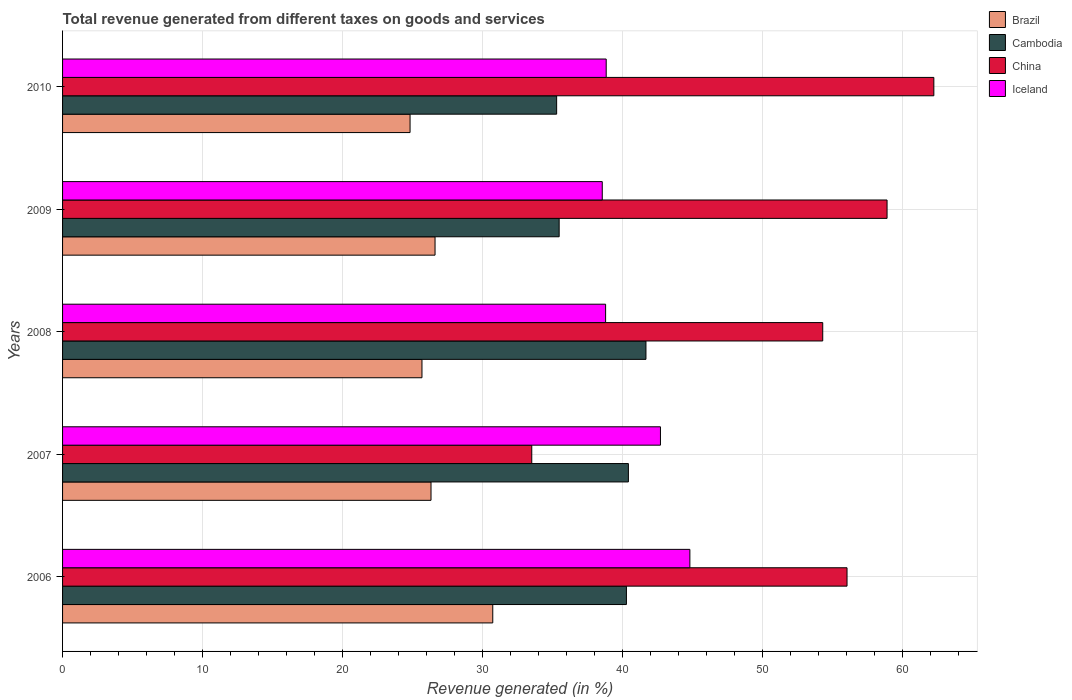Are the number of bars per tick equal to the number of legend labels?
Provide a short and direct response. Yes. Are the number of bars on each tick of the Y-axis equal?
Give a very brief answer. Yes. How many bars are there on the 1st tick from the top?
Your response must be concise. 4. What is the total revenue generated in Cambodia in 2008?
Your response must be concise. 41.67. Across all years, what is the maximum total revenue generated in China?
Your response must be concise. 62.23. Across all years, what is the minimum total revenue generated in Brazil?
Offer a terse response. 24.82. In which year was the total revenue generated in Cambodia maximum?
Keep it short and to the point. 2008. In which year was the total revenue generated in Brazil minimum?
Offer a very short reply. 2010. What is the total total revenue generated in Cambodia in the graph?
Keep it short and to the point. 193.12. What is the difference between the total revenue generated in Iceland in 2007 and that in 2008?
Your response must be concise. 3.92. What is the difference between the total revenue generated in Brazil in 2006 and the total revenue generated in Cambodia in 2009?
Your answer should be very brief. -4.74. What is the average total revenue generated in Iceland per year?
Offer a very short reply. 40.74. In the year 2008, what is the difference between the total revenue generated in Cambodia and total revenue generated in Brazil?
Offer a terse response. 16. What is the ratio of the total revenue generated in China in 2007 to that in 2010?
Your response must be concise. 0.54. Is the difference between the total revenue generated in Cambodia in 2006 and 2008 greater than the difference between the total revenue generated in Brazil in 2006 and 2008?
Offer a very short reply. No. What is the difference between the highest and the second highest total revenue generated in Cambodia?
Give a very brief answer. 1.25. What is the difference between the highest and the lowest total revenue generated in China?
Keep it short and to the point. 28.72. In how many years, is the total revenue generated in Brazil greater than the average total revenue generated in Brazil taken over all years?
Ensure brevity in your answer.  1. Is it the case that in every year, the sum of the total revenue generated in Cambodia and total revenue generated in China is greater than the sum of total revenue generated in Brazil and total revenue generated in Iceland?
Offer a terse response. Yes. What does the 3rd bar from the top in 2010 represents?
Make the answer very short. Cambodia. What does the 2nd bar from the bottom in 2009 represents?
Provide a short and direct response. Cambodia. Is it the case that in every year, the sum of the total revenue generated in China and total revenue generated in Brazil is greater than the total revenue generated in Iceland?
Provide a short and direct response. Yes. How many bars are there?
Your answer should be compact. 20. Are all the bars in the graph horizontal?
Provide a short and direct response. Yes. What is the difference between two consecutive major ticks on the X-axis?
Keep it short and to the point. 10. Are the values on the major ticks of X-axis written in scientific E-notation?
Your response must be concise. No. Does the graph contain grids?
Offer a very short reply. Yes. How are the legend labels stacked?
Offer a terse response. Vertical. What is the title of the graph?
Provide a short and direct response. Total revenue generated from different taxes on goods and services. What is the label or title of the X-axis?
Offer a very short reply. Revenue generated (in %). What is the Revenue generated (in %) of Brazil in 2006?
Ensure brevity in your answer.  30.73. What is the Revenue generated (in %) of Cambodia in 2006?
Your answer should be very brief. 40.28. What is the Revenue generated (in %) of China in 2006?
Give a very brief answer. 56.03. What is the Revenue generated (in %) in Iceland in 2006?
Provide a succinct answer. 44.81. What is the Revenue generated (in %) in Brazil in 2007?
Provide a succinct answer. 26.32. What is the Revenue generated (in %) in Cambodia in 2007?
Provide a short and direct response. 40.42. What is the Revenue generated (in %) of China in 2007?
Offer a very short reply. 33.51. What is the Revenue generated (in %) in Iceland in 2007?
Keep it short and to the point. 42.71. What is the Revenue generated (in %) in Brazil in 2008?
Provide a succinct answer. 25.67. What is the Revenue generated (in %) of Cambodia in 2008?
Make the answer very short. 41.67. What is the Revenue generated (in %) of China in 2008?
Ensure brevity in your answer.  54.3. What is the Revenue generated (in %) of Iceland in 2008?
Offer a terse response. 38.79. What is the Revenue generated (in %) in Brazil in 2009?
Your response must be concise. 26.61. What is the Revenue generated (in %) of Cambodia in 2009?
Give a very brief answer. 35.47. What is the Revenue generated (in %) in China in 2009?
Offer a terse response. 58.89. What is the Revenue generated (in %) in Iceland in 2009?
Your answer should be very brief. 38.55. What is the Revenue generated (in %) in Brazil in 2010?
Offer a very short reply. 24.82. What is the Revenue generated (in %) in Cambodia in 2010?
Offer a terse response. 35.29. What is the Revenue generated (in %) of China in 2010?
Your answer should be compact. 62.23. What is the Revenue generated (in %) of Iceland in 2010?
Give a very brief answer. 38.83. Across all years, what is the maximum Revenue generated (in %) of Brazil?
Provide a short and direct response. 30.73. Across all years, what is the maximum Revenue generated (in %) in Cambodia?
Offer a very short reply. 41.67. Across all years, what is the maximum Revenue generated (in %) of China?
Keep it short and to the point. 62.23. Across all years, what is the maximum Revenue generated (in %) of Iceland?
Your response must be concise. 44.81. Across all years, what is the minimum Revenue generated (in %) of Brazil?
Your answer should be very brief. 24.82. Across all years, what is the minimum Revenue generated (in %) of Cambodia?
Your response must be concise. 35.29. Across all years, what is the minimum Revenue generated (in %) of China?
Ensure brevity in your answer.  33.51. Across all years, what is the minimum Revenue generated (in %) of Iceland?
Keep it short and to the point. 38.55. What is the total Revenue generated (in %) of Brazil in the graph?
Provide a short and direct response. 134.14. What is the total Revenue generated (in %) in Cambodia in the graph?
Your answer should be compact. 193.12. What is the total Revenue generated (in %) in China in the graph?
Keep it short and to the point. 264.97. What is the total Revenue generated (in %) in Iceland in the graph?
Keep it short and to the point. 203.68. What is the difference between the Revenue generated (in %) of Brazil in 2006 and that in 2007?
Offer a very short reply. 4.41. What is the difference between the Revenue generated (in %) in Cambodia in 2006 and that in 2007?
Ensure brevity in your answer.  -0.14. What is the difference between the Revenue generated (in %) in China in 2006 and that in 2007?
Keep it short and to the point. 22.52. What is the difference between the Revenue generated (in %) of Iceland in 2006 and that in 2007?
Your response must be concise. 2.1. What is the difference between the Revenue generated (in %) in Brazil in 2006 and that in 2008?
Offer a very short reply. 5.06. What is the difference between the Revenue generated (in %) of Cambodia in 2006 and that in 2008?
Your answer should be very brief. -1.39. What is the difference between the Revenue generated (in %) in China in 2006 and that in 2008?
Keep it short and to the point. 1.73. What is the difference between the Revenue generated (in %) in Iceland in 2006 and that in 2008?
Give a very brief answer. 6.02. What is the difference between the Revenue generated (in %) of Brazil in 2006 and that in 2009?
Ensure brevity in your answer.  4.12. What is the difference between the Revenue generated (in %) of Cambodia in 2006 and that in 2009?
Give a very brief answer. 4.8. What is the difference between the Revenue generated (in %) in China in 2006 and that in 2009?
Keep it short and to the point. -2.86. What is the difference between the Revenue generated (in %) of Iceland in 2006 and that in 2009?
Your response must be concise. 6.26. What is the difference between the Revenue generated (in %) of Brazil in 2006 and that in 2010?
Provide a short and direct response. 5.91. What is the difference between the Revenue generated (in %) of Cambodia in 2006 and that in 2010?
Provide a short and direct response. 4.99. What is the difference between the Revenue generated (in %) in China in 2006 and that in 2010?
Make the answer very short. -6.2. What is the difference between the Revenue generated (in %) of Iceland in 2006 and that in 2010?
Your response must be concise. 5.98. What is the difference between the Revenue generated (in %) in Brazil in 2007 and that in 2008?
Your answer should be compact. 0.65. What is the difference between the Revenue generated (in %) in Cambodia in 2007 and that in 2008?
Offer a terse response. -1.25. What is the difference between the Revenue generated (in %) of China in 2007 and that in 2008?
Your answer should be very brief. -20.78. What is the difference between the Revenue generated (in %) in Iceland in 2007 and that in 2008?
Make the answer very short. 3.92. What is the difference between the Revenue generated (in %) of Brazil in 2007 and that in 2009?
Keep it short and to the point. -0.29. What is the difference between the Revenue generated (in %) in Cambodia in 2007 and that in 2009?
Provide a short and direct response. 4.95. What is the difference between the Revenue generated (in %) in China in 2007 and that in 2009?
Keep it short and to the point. -25.38. What is the difference between the Revenue generated (in %) of Iceland in 2007 and that in 2009?
Ensure brevity in your answer.  4.16. What is the difference between the Revenue generated (in %) in Brazil in 2007 and that in 2010?
Provide a short and direct response. 1.5. What is the difference between the Revenue generated (in %) in Cambodia in 2007 and that in 2010?
Your answer should be compact. 5.13. What is the difference between the Revenue generated (in %) in China in 2007 and that in 2010?
Offer a terse response. -28.72. What is the difference between the Revenue generated (in %) in Iceland in 2007 and that in 2010?
Ensure brevity in your answer.  3.88. What is the difference between the Revenue generated (in %) of Brazil in 2008 and that in 2009?
Give a very brief answer. -0.93. What is the difference between the Revenue generated (in %) of Cambodia in 2008 and that in 2009?
Make the answer very short. 6.2. What is the difference between the Revenue generated (in %) in China in 2008 and that in 2009?
Provide a succinct answer. -4.59. What is the difference between the Revenue generated (in %) in Iceland in 2008 and that in 2009?
Offer a terse response. 0.24. What is the difference between the Revenue generated (in %) of Brazil in 2008 and that in 2010?
Keep it short and to the point. 0.85. What is the difference between the Revenue generated (in %) in Cambodia in 2008 and that in 2010?
Keep it short and to the point. 6.38. What is the difference between the Revenue generated (in %) in China in 2008 and that in 2010?
Your answer should be very brief. -7.94. What is the difference between the Revenue generated (in %) of Iceland in 2008 and that in 2010?
Offer a very short reply. -0.04. What is the difference between the Revenue generated (in %) in Brazil in 2009 and that in 2010?
Give a very brief answer. 1.78. What is the difference between the Revenue generated (in %) of Cambodia in 2009 and that in 2010?
Make the answer very short. 0.18. What is the difference between the Revenue generated (in %) in China in 2009 and that in 2010?
Your answer should be compact. -3.34. What is the difference between the Revenue generated (in %) of Iceland in 2009 and that in 2010?
Provide a short and direct response. -0.28. What is the difference between the Revenue generated (in %) in Brazil in 2006 and the Revenue generated (in %) in Cambodia in 2007?
Offer a terse response. -9.69. What is the difference between the Revenue generated (in %) of Brazil in 2006 and the Revenue generated (in %) of China in 2007?
Provide a short and direct response. -2.79. What is the difference between the Revenue generated (in %) of Brazil in 2006 and the Revenue generated (in %) of Iceland in 2007?
Give a very brief answer. -11.98. What is the difference between the Revenue generated (in %) of Cambodia in 2006 and the Revenue generated (in %) of China in 2007?
Provide a succinct answer. 6.76. What is the difference between the Revenue generated (in %) of Cambodia in 2006 and the Revenue generated (in %) of Iceland in 2007?
Offer a terse response. -2.43. What is the difference between the Revenue generated (in %) in China in 2006 and the Revenue generated (in %) in Iceland in 2007?
Ensure brevity in your answer.  13.33. What is the difference between the Revenue generated (in %) in Brazil in 2006 and the Revenue generated (in %) in Cambodia in 2008?
Your answer should be compact. -10.94. What is the difference between the Revenue generated (in %) in Brazil in 2006 and the Revenue generated (in %) in China in 2008?
Ensure brevity in your answer.  -23.57. What is the difference between the Revenue generated (in %) in Brazil in 2006 and the Revenue generated (in %) in Iceland in 2008?
Provide a succinct answer. -8.06. What is the difference between the Revenue generated (in %) in Cambodia in 2006 and the Revenue generated (in %) in China in 2008?
Offer a terse response. -14.02. What is the difference between the Revenue generated (in %) of Cambodia in 2006 and the Revenue generated (in %) of Iceland in 2008?
Your response must be concise. 1.49. What is the difference between the Revenue generated (in %) in China in 2006 and the Revenue generated (in %) in Iceland in 2008?
Offer a terse response. 17.24. What is the difference between the Revenue generated (in %) in Brazil in 2006 and the Revenue generated (in %) in Cambodia in 2009?
Your answer should be compact. -4.74. What is the difference between the Revenue generated (in %) of Brazil in 2006 and the Revenue generated (in %) of China in 2009?
Provide a short and direct response. -28.16. What is the difference between the Revenue generated (in %) in Brazil in 2006 and the Revenue generated (in %) in Iceland in 2009?
Your answer should be compact. -7.82. What is the difference between the Revenue generated (in %) of Cambodia in 2006 and the Revenue generated (in %) of China in 2009?
Provide a succinct answer. -18.62. What is the difference between the Revenue generated (in %) of Cambodia in 2006 and the Revenue generated (in %) of Iceland in 2009?
Your response must be concise. 1.73. What is the difference between the Revenue generated (in %) in China in 2006 and the Revenue generated (in %) in Iceland in 2009?
Make the answer very short. 17.48. What is the difference between the Revenue generated (in %) of Brazil in 2006 and the Revenue generated (in %) of Cambodia in 2010?
Your response must be concise. -4.56. What is the difference between the Revenue generated (in %) in Brazil in 2006 and the Revenue generated (in %) in China in 2010?
Offer a very short reply. -31.51. What is the difference between the Revenue generated (in %) in Brazil in 2006 and the Revenue generated (in %) in Iceland in 2010?
Ensure brevity in your answer.  -8.1. What is the difference between the Revenue generated (in %) of Cambodia in 2006 and the Revenue generated (in %) of China in 2010?
Your answer should be very brief. -21.96. What is the difference between the Revenue generated (in %) in Cambodia in 2006 and the Revenue generated (in %) in Iceland in 2010?
Provide a short and direct response. 1.45. What is the difference between the Revenue generated (in %) of China in 2006 and the Revenue generated (in %) of Iceland in 2010?
Make the answer very short. 17.2. What is the difference between the Revenue generated (in %) of Brazil in 2007 and the Revenue generated (in %) of Cambodia in 2008?
Provide a succinct answer. -15.35. What is the difference between the Revenue generated (in %) in Brazil in 2007 and the Revenue generated (in %) in China in 2008?
Make the answer very short. -27.98. What is the difference between the Revenue generated (in %) of Brazil in 2007 and the Revenue generated (in %) of Iceland in 2008?
Make the answer very short. -12.47. What is the difference between the Revenue generated (in %) of Cambodia in 2007 and the Revenue generated (in %) of China in 2008?
Your answer should be compact. -13.88. What is the difference between the Revenue generated (in %) of Cambodia in 2007 and the Revenue generated (in %) of Iceland in 2008?
Offer a terse response. 1.63. What is the difference between the Revenue generated (in %) of China in 2007 and the Revenue generated (in %) of Iceland in 2008?
Provide a succinct answer. -5.27. What is the difference between the Revenue generated (in %) of Brazil in 2007 and the Revenue generated (in %) of Cambodia in 2009?
Ensure brevity in your answer.  -9.15. What is the difference between the Revenue generated (in %) of Brazil in 2007 and the Revenue generated (in %) of China in 2009?
Ensure brevity in your answer.  -32.58. What is the difference between the Revenue generated (in %) of Brazil in 2007 and the Revenue generated (in %) of Iceland in 2009?
Your answer should be compact. -12.23. What is the difference between the Revenue generated (in %) of Cambodia in 2007 and the Revenue generated (in %) of China in 2009?
Your answer should be compact. -18.48. What is the difference between the Revenue generated (in %) in Cambodia in 2007 and the Revenue generated (in %) in Iceland in 2009?
Offer a very short reply. 1.87. What is the difference between the Revenue generated (in %) in China in 2007 and the Revenue generated (in %) in Iceland in 2009?
Provide a succinct answer. -5.04. What is the difference between the Revenue generated (in %) in Brazil in 2007 and the Revenue generated (in %) in Cambodia in 2010?
Offer a very short reply. -8.97. What is the difference between the Revenue generated (in %) in Brazil in 2007 and the Revenue generated (in %) in China in 2010?
Give a very brief answer. -35.92. What is the difference between the Revenue generated (in %) of Brazil in 2007 and the Revenue generated (in %) of Iceland in 2010?
Keep it short and to the point. -12.51. What is the difference between the Revenue generated (in %) in Cambodia in 2007 and the Revenue generated (in %) in China in 2010?
Provide a short and direct response. -21.82. What is the difference between the Revenue generated (in %) in Cambodia in 2007 and the Revenue generated (in %) in Iceland in 2010?
Offer a terse response. 1.59. What is the difference between the Revenue generated (in %) in China in 2007 and the Revenue generated (in %) in Iceland in 2010?
Provide a short and direct response. -5.32. What is the difference between the Revenue generated (in %) in Brazil in 2008 and the Revenue generated (in %) in Cambodia in 2009?
Offer a terse response. -9.8. What is the difference between the Revenue generated (in %) of Brazil in 2008 and the Revenue generated (in %) of China in 2009?
Provide a succinct answer. -33.22. What is the difference between the Revenue generated (in %) of Brazil in 2008 and the Revenue generated (in %) of Iceland in 2009?
Keep it short and to the point. -12.88. What is the difference between the Revenue generated (in %) in Cambodia in 2008 and the Revenue generated (in %) in China in 2009?
Your response must be concise. -17.22. What is the difference between the Revenue generated (in %) of Cambodia in 2008 and the Revenue generated (in %) of Iceland in 2009?
Offer a terse response. 3.12. What is the difference between the Revenue generated (in %) of China in 2008 and the Revenue generated (in %) of Iceland in 2009?
Your answer should be compact. 15.75. What is the difference between the Revenue generated (in %) in Brazil in 2008 and the Revenue generated (in %) in Cambodia in 2010?
Your answer should be compact. -9.62. What is the difference between the Revenue generated (in %) in Brazil in 2008 and the Revenue generated (in %) in China in 2010?
Ensure brevity in your answer.  -36.56. What is the difference between the Revenue generated (in %) in Brazil in 2008 and the Revenue generated (in %) in Iceland in 2010?
Offer a terse response. -13.16. What is the difference between the Revenue generated (in %) in Cambodia in 2008 and the Revenue generated (in %) in China in 2010?
Make the answer very short. -20.56. What is the difference between the Revenue generated (in %) of Cambodia in 2008 and the Revenue generated (in %) of Iceland in 2010?
Provide a short and direct response. 2.84. What is the difference between the Revenue generated (in %) in China in 2008 and the Revenue generated (in %) in Iceland in 2010?
Provide a short and direct response. 15.47. What is the difference between the Revenue generated (in %) in Brazil in 2009 and the Revenue generated (in %) in Cambodia in 2010?
Provide a short and direct response. -8.69. What is the difference between the Revenue generated (in %) in Brazil in 2009 and the Revenue generated (in %) in China in 2010?
Ensure brevity in your answer.  -35.63. What is the difference between the Revenue generated (in %) of Brazil in 2009 and the Revenue generated (in %) of Iceland in 2010?
Offer a very short reply. -12.22. What is the difference between the Revenue generated (in %) of Cambodia in 2009 and the Revenue generated (in %) of China in 2010?
Provide a short and direct response. -26.76. What is the difference between the Revenue generated (in %) of Cambodia in 2009 and the Revenue generated (in %) of Iceland in 2010?
Your answer should be compact. -3.36. What is the difference between the Revenue generated (in %) in China in 2009 and the Revenue generated (in %) in Iceland in 2010?
Offer a very short reply. 20.06. What is the average Revenue generated (in %) in Brazil per year?
Make the answer very short. 26.83. What is the average Revenue generated (in %) in Cambodia per year?
Your answer should be compact. 38.62. What is the average Revenue generated (in %) in China per year?
Ensure brevity in your answer.  52.99. What is the average Revenue generated (in %) of Iceland per year?
Your answer should be compact. 40.74. In the year 2006, what is the difference between the Revenue generated (in %) of Brazil and Revenue generated (in %) of Cambodia?
Make the answer very short. -9.55. In the year 2006, what is the difference between the Revenue generated (in %) in Brazil and Revenue generated (in %) in China?
Provide a succinct answer. -25.3. In the year 2006, what is the difference between the Revenue generated (in %) in Brazil and Revenue generated (in %) in Iceland?
Your response must be concise. -14.08. In the year 2006, what is the difference between the Revenue generated (in %) of Cambodia and Revenue generated (in %) of China?
Give a very brief answer. -15.76. In the year 2006, what is the difference between the Revenue generated (in %) of Cambodia and Revenue generated (in %) of Iceland?
Offer a terse response. -4.53. In the year 2006, what is the difference between the Revenue generated (in %) in China and Revenue generated (in %) in Iceland?
Offer a very short reply. 11.23. In the year 2007, what is the difference between the Revenue generated (in %) in Brazil and Revenue generated (in %) in Cambodia?
Give a very brief answer. -14.1. In the year 2007, what is the difference between the Revenue generated (in %) of Brazil and Revenue generated (in %) of China?
Ensure brevity in your answer.  -7.2. In the year 2007, what is the difference between the Revenue generated (in %) of Brazil and Revenue generated (in %) of Iceland?
Keep it short and to the point. -16.39. In the year 2007, what is the difference between the Revenue generated (in %) in Cambodia and Revenue generated (in %) in China?
Your answer should be very brief. 6.9. In the year 2007, what is the difference between the Revenue generated (in %) in Cambodia and Revenue generated (in %) in Iceland?
Your answer should be very brief. -2.29. In the year 2007, what is the difference between the Revenue generated (in %) in China and Revenue generated (in %) in Iceland?
Make the answer very short. -9.19. In the year 2008, what is the difference between the Revenue generated (in %) in Brazil and Revenue generated (in %) in Cambodia?
Your answer should be very brief. -16. In the year 2008, what is the difference between the Revenue generated (in %) in Brazil and Revenue generated (in %) in China?
Your answer should be compact. -28.63. In the year 2008, what is the difference between the Revenue generated (in %) in Brazil and Revenue generated (in %) in Iceland?
Give a very brief answer. -13.12. In the year 2008, what is the difference between the Revenue generated (in %) of Cambodia and Revenue generated (in %) of China?
Provide a short and direct response. -12.63. In the year 2008, what is the difference between the Revenue generated (in %) in Cambodia and Revenue generated (in %) in Iceland?
Keep it short and to the point. 2.88. In the year 2008, what is the difference between the Revenue generated (in %) in China and Revenue generated (in %) in Iceland?
Your answer should be very brief. 15.51. In the year 2009, what is the difference between the Revenue generated (in %) of Brazil and Revenue generated (in %) of Cambodia?
Your answer should be very brief. -8.87. In the year 2009, what is the difference between the Revenue generated (in %) in Brazil and Revenue generated (in %) in China?
Your response must be concise. -32.29. In the year 2009, what is the difference between the Revenue generated (in %) of Brazil and Revenue generated (in %) of Iceland?
Keep it short and to the point. -11.94. In the year 2009, what is the difference between the Revenue generated (in %) of Cambodia and Revenue generated (in %) of China?
Ensure brevity in your answer.  -23.42. In the year 2009, what is the difference between the Revenue generated (in %) of Cambodia and Revenue generated (in %) of Iceland?
Offer a very short reply. -3.08. In the year 2009, what is the difference between the Revenue generated (in %) of China and Revenue generated (in %) of Iceland?
Your response must be concise. 20.34. In the year 2010, what is the difference between the Revenue generated (in %) in Brazil and Revenue generated (in %) in Cambodia?
Offer a terse response. -10.47. In the year 2010, what is the difference between the Revenue generated (in %) of Brazil and Revenue generated (in %) of China?
Make the answer very short. -37.41. In the year 2010, what is the difference between the Revenue generated (in %) of Brazil and Revenue generated (in %) of Iceland?
Keep it short and to the point. -14.01. In the year 2010, what is the difference between the Revenue generated (in %) in Cambodia and Revenue generated (in %) in China?
Provide a succinct answer. -26.94. In the year 2010, what is the difference between the Revenue generated (in %) in Cambodia and Revenue generated (in %) in Iceland?
Provide a short and direct response. -3.54. In the year 2010, what is the difference between the Revenue generated (in %) in China and Revenue generated (in %) in Iceland?
Offer a very short reply. 23.4. What is the ratio of the Revenue generated (in %) in Brazil in 2006 to that in 2007?
Keep it short and to the point. 1.17. What is the ratio of the Revenue generated (in %) in Cambodia in 2006 to that in 2007?
Your answer should be compact. 1. What is the ratio of the Revenue generated (in %) of China in 2006 to that in 2007?
Your answer should be compact. 1.67. What is the ratio of the Revenue generated (in %) of Iceland in 2006 to that in 2007?
Provide a succinct answer. 1.05. What is the ratio of the Revenue generated (in %) in Brazil in 2006 to that in 2008?
Make the answer very short. 1.2. What is the ratio of the Revenue generated (in %) of Cambodia in 2006 to that in 2008?
Provide a succinct answer. 0.97. What is the ratio of the Revenue generated (in %) in China in 2006 to that in 2008?
Your answer should be compact. 1.03. What is the ratio of the Revenue generated (in %) of Iceland in 2006 to that in 2008?
Your answer should be very brief. 1.16. What is the ratio of the Revenue generated (in %) of Brazil in 2006 to that in 2009?
Make the answer very short. 1.16. What is the ratio of the Revenue generated (in %) of Cambodia in 2006 to that in 2009?
Your answer should be compact. 1.14. What is the ratio of the Revenue generated (in %) in China in 2006 to that in 2009?
Make the answer very short. 0.95. What is the ratio of the Revenue generated (in %) of Iceland in 2006 to that in 2009?
Keep it short and to the point. 1.16. What is the ratio of the Revenue generated (in %) in Brazil in 2006 to that in 2010?
Provide a succinct answer. 1.24. What is the ratio of the Revenue generated (in %) in Cambodia in 2006 to that in 2010?
Keep it short and to the point. 1.14. What is the ratio of the Revenue generated (in %) in China in 2006 to that in 2010?
Ensure brevity in your answer.  0.9. What is the ratio of the Revenue generated (in %) in Iceland in 2006 to that in 2010?
Give a very brief answer. 1.15. What is the ratio of the Revenue generated (in %) in Brazil in 2007 to that in 2008?
Your response must be concise. 1.03. What is the ratio of the Revenue generated (in %) of Cambodia in 2007 to that in 2008?
Ensure brevity in your answer.  0.97. What is the ratio of the Revenue generated (in %) in China in 2007 to that in 2008?
Make the answer very short. 0.62. What is the ratio of the Revenue generated (in %) of Iceland in 2007 to that in 2008?
Offer a very short reply. 1.1. What is the ratio of the Revenue generated (in %) of Cambodia in 2007 to that in 2009?
Your response must be concise. 1.14. What is the ratio of the Revenue generated (in %) in China in 2007 to that in 2009?
Your answer should be very brief. 0.57. What is the ratio of the Revenue generated (in %) of Iceland in 2007 to that in 2009?
Give a very brief answer. 1.11. What is the ratio of the Revenue generated (in %) in Brazil in 2007 to that in 2010?
Offer a terse response. 1.06. What is the ratio of the Revenue generated (in %) in Cambodia in 2007 to that in 2010?
Provide a short and direct response. 1.15. What is the ratio of the Revenue generated (in %) of China in 2007 to that in 2010?
Offer a terse response. 0.54. What is the ratio of the Revenue generated (in %) of Iceland in 2007 to that in 2010?
Make the answer very short. 1.1. What is the ratio of the Revenue generated (in %) of Brazil in 2008 to that in 2009?
Make the answer very short. 0.96. What is the ratio of the Revenue generated (in %) in Cambodia in 2008 to that in 2009?
Your response must be concise. 1.17. What is the ratio of the Revenue generated (in %) of China in 2008 to that in 2009?
Provide a succinct answer. 0.92. What is the ratio of the Revenue generated (in %) of Brazil in 2008 to that in 2010?
Offer a very short reply. 1.03. What is the ratio of the Revenue generated (in %) of Cambodia in 2008 to that in 2010?
Offer a terse response. 1.18. What is the ratio of the Revenue generated (in %) in China in 2008 to that in 2010?
Offer a very short reply. 0.87. What is the ratio of the Revenue generated (in %) in Brazil in 2009 to that in 2010?
Provide a short and direct response. 1.07. What is the ratio of the Revenue generated (in %) of China in 2009 to that in 2010?
Give a very brief answer. 0.95. What is the difference between the highest and the second highest Revenue generated (in %) of Brazil?
Give a very brief answer. 4.12. What is the difference between the highest and the second highest Revenue generated (in %) in Cambodia?
Offer a very short reply. 1.25. What is the difference between the highest and the second highest Revenue generated (in %) of China?
Your answer should be very brief. 3.34. What is the difference between the highest and the second highest Revenue generated (in %) of Iceland?
Ensure brevity in your answer.  2.1. What is the difference between the highest and the lowest Revenue generated (in %) of Brazil?
Offer a very short reply. 5.91. What is the difference between the highest and the lowest Revenue generated (in %) in Cambodia?
Provide a short and direct response. 6.38. What is the difference between the highest and the lowest Revenue generated (in %) in China?
Your answer should be very brief. 28.72. What is the difference between the highest and the lowest Revenue generated (in %) in Iceland?
Your answer should be very brief. 6.26. 